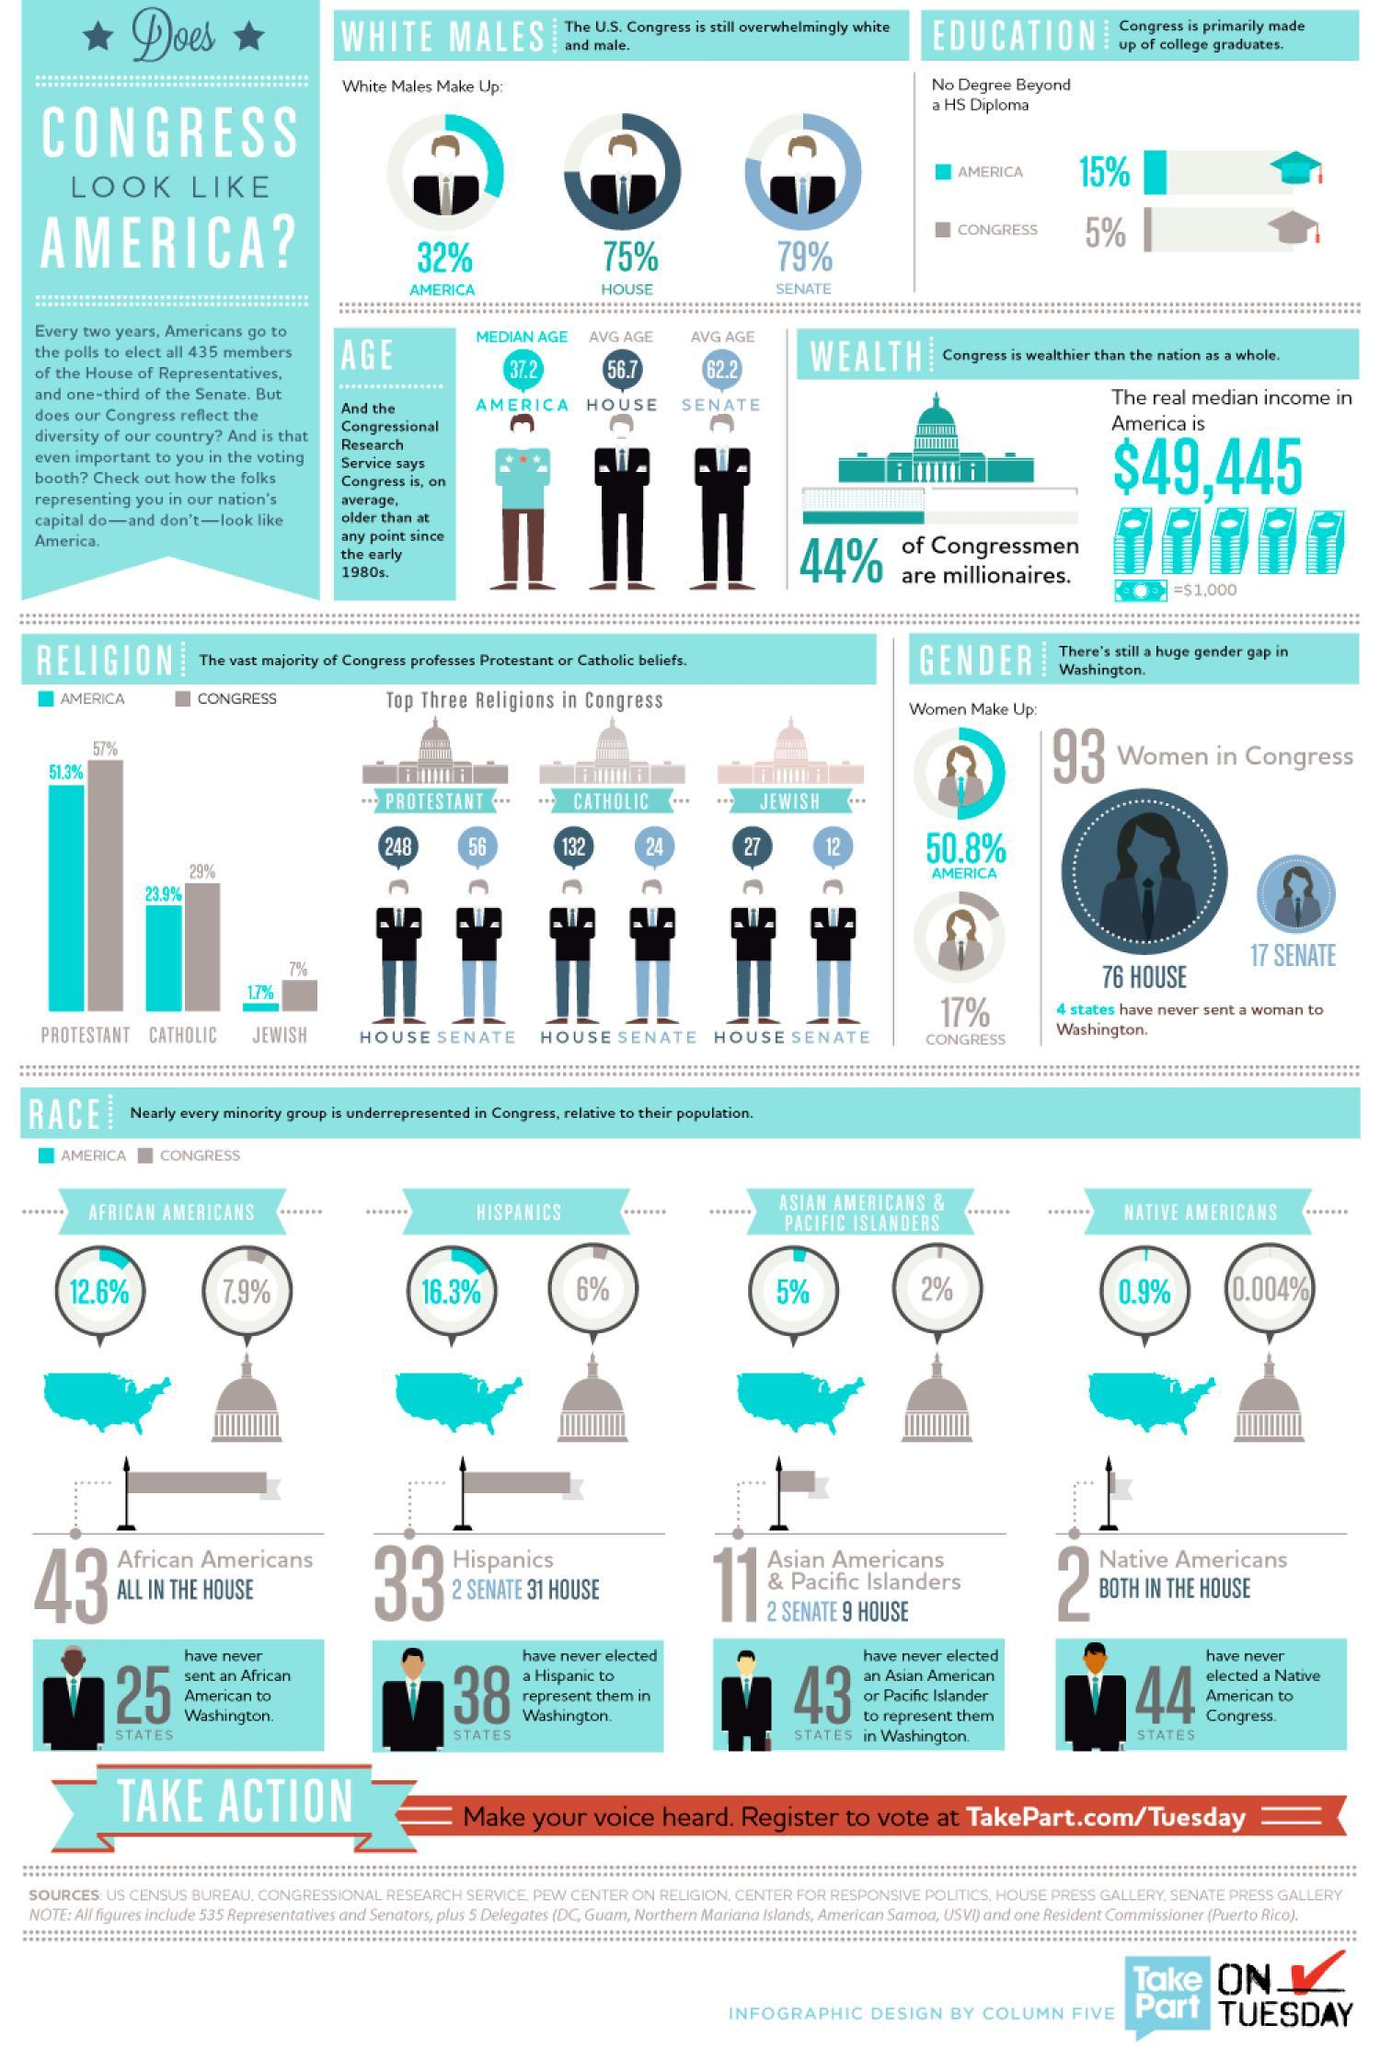What percentage of American population are Native Americans ?
Answer the question with a short phrase. 0.9% Who makes  up 5% of American population? Asian Americans & Pacific Islanders How many Catholics are there in the House? 132 What percent of Congress is made up of African Americans? 7.9% What is the percent of white males in the US? 32% How many Jewish people are there in the Senate? 12 What percent of Americans are Catholic? 23.9% How many Protestants are in the Senate? 56 What percent of the Congress is made up of Women? 17% What percent of American population are Hispanics? 16.3% 